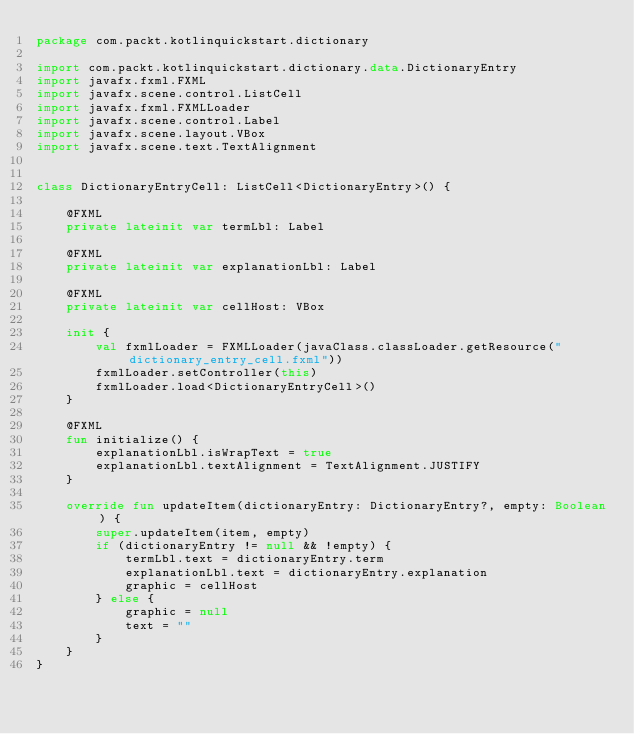Convert code to text. <code><loc_0><loc_0><loc_500><loc_500><_Kotlin_>package com.packt.kotlinquickstart.dictionary

import com.packt.kotlinquickstart.dictionary.data.DictionaryEntry
import javafx.fxml.FXML
import javafx.scene.control.ListCell
import javafx.fxml.FXMLLoader
import javafx.scene.control.Label
import javafx.scene.layout.VBox
import javafx.scene.text.TextAlignment


class DictionaryEntryCell: ListCell<DictionaryEntry>() {

    @FXML
    private lateinit var termLbl: Label

    @FXML
    private lateinit var explanationLbl: Label

    @FXML
    private lateinit var cellHost: VBox

    init {
        val fxmlLoader = FXMLLoader(javaClass.classLoader.getResource("dictionary_entry_cell.fxml"))
        fxmlLoader.setController(this)
        fxmlLoader.load<DictionaryEntryCell>()
    }

    @FXML
    fun initialize() {
        explanationLbl.isWrapText = true
        explanationLbl.textAlignment = TextAlignment.JUSTIFY
    }

    override fun updateItem(dictionaryEntry: DictionaryEntry?, empty: Boolean) {
        super.updateItem(item, empty)
        if (dictionaryEntry != null && !empty) {
            termLbl.text = dictionaryEntry.term
            explanationLbl.text = dictionaryEntry.explanation
            graphic = cellHost
        } else {
            graphic = null
            text = ""
        }
    }
}</code> 